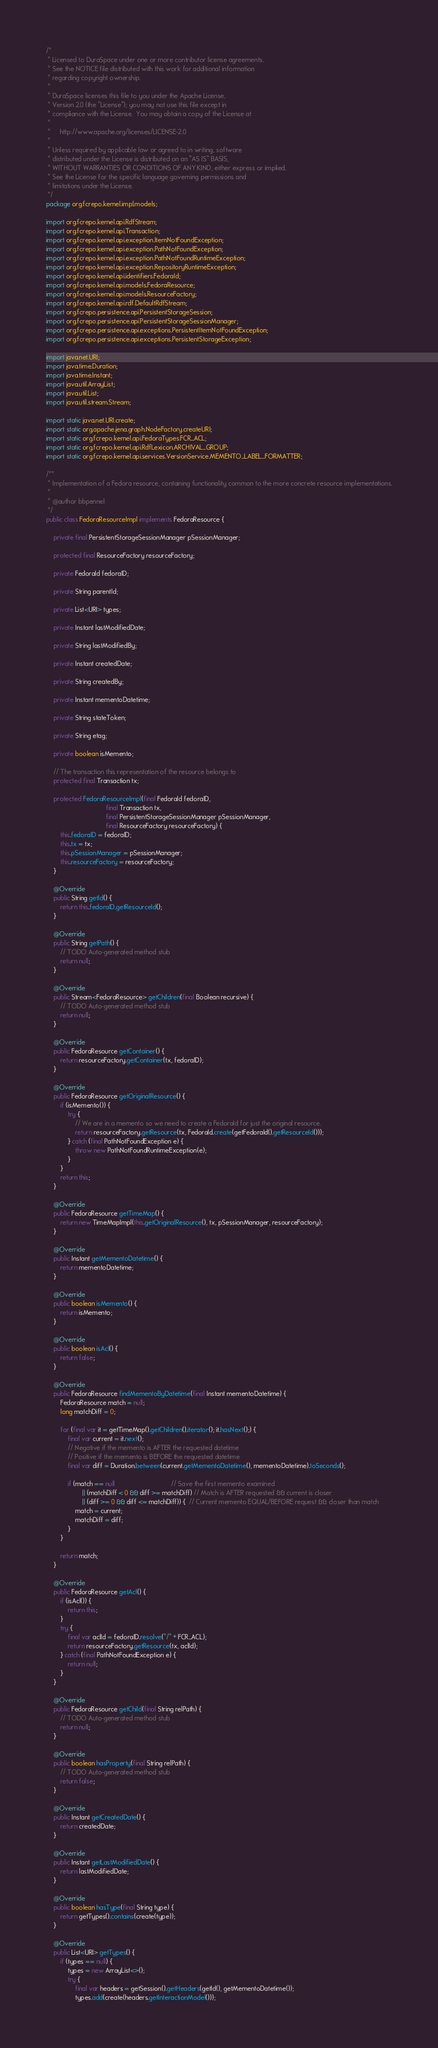<code> <loc_0><loc_0><loc_500><loc_500><_Java_>/*
 * Licensed to DuraSpace under one or more contributor license agreements.
 * See the NOTICE file distributed with this work for additional information
 * regarding copyright ownership.
 *
 * DuraSpace licenses this file to you under the Apache License,
 * Version 2.0 (the "License"); you may not use this file except in
 * compliance with the License.  You may obtain a copy of the License at
 *
 *     http://www.apache.org/licenses/LICENSE-2.0
 *
 * Unless required by applicable law or agreed to in writing, software
 * distributed under the License is distributed on an "AS IS" BASIS,
 * WITHOUT WARRANTIES OR CONDITIONS OF ANY KIND, either express or implied.
 * See the License for the specific language governing permissions and
 * limitations under the License.
 */
package org.fcrepo.kernel.impl.models;

import org.fcrepo.kernel.api.RdfStream;
import org.fcrepo.kernel.api.Transaction;
import org.fcrepo.kernel.api.exception.ItemNotFoundException;
import org.fcrepo.kernel.api.exception.PathNotFoundException;
import org.fcrepo.kernel.api.exception.PathNotFoundRuntimeException;
import org.fcrepo.kernel.api.exception.RepositoryRuntimeException;
import org.fcrepo.kernel.api.identifiers.FedoraId;
import org.fcrepo.kernel.api.models.FedoraResource;
import org.fcrepo.kernel.api.models.ResourceFactory;
import org.fcrepo.kernel.api.rdf.DefaultRdfStream;
import org.fcrepo.persistence.api.PersistentStorageSession;
import org.fcrepo.persistence.api.PersistentStorageSessionManager;
import org.fcrepo.persistence.api.exceptions.PersistentItemNotFoundException;
import org.fcrepo.persistence.api.exceptions.PersistentStorageException;

import java.net.URI;
import java.time.Duration;
import java.time.Instant;
import java.util.ArrayList;
import java.util.List;
import java.util.stream.Stream;

import static java.net.URI.create;
import static org.apache.jena.graph.NodeFactory.createURI;
import static org.fcrepo.kernel.api.FedoraTypes.FCR_ACL;
import static org.fcrepo.kernel.api.RdfLexicon.ARCHIVAL_GROUP;
import static org.fcrepo.kernel.api.services.VersionService.MEMENTO_LABEL_FORMATTER;

/**
 * Implementation of a Fedora resource, containing functionality common to the more concrete resource implementations.
 *
 * @author bbpennel
 */
public class FedoraResourceImpl implements FedoraResource {

    private final PersistentStorageSessionManager pSessionManager;

    protected final ResourceFactory resourceFactory;

    private FedoraId fedoraID;

    private String parentId;

    private List<URI> types;

    private Instant lastModifiedDate;

    private String lastModifiedBy;

    private Instant createdDate;

    private String createdBy;

    private Instant mementoDatetime;

    private String stateToken;

    private String etag;

    private boolean isMemento;

    // The transaction this representation of the resource belongs to
    protected final Transaction tx;

    protected FedoraResourceImpl(final FedoraId fedoraID,
                                 final Transaction tx,
                                 final PersistentStorageSessionManager pSessionManager,
                                 final ResourceFactory resourceFactory) {
        this.fedoraID = fedoraID;
        this.tx = tx;
        this.pSessionManager = pSessionManager;
        this.resourceFactory = resourceFactory;
    }

    @Override
    public String getId() {
        return this.fedoraID.getResourceId();
    }

    @Override
    public String getPath() {
        // TODO Auto-generated method stub
        return null;
    }

    @Override
    public Stream<FedoraResource> getChildren(final Boolean recursive) {
        // TODO Auto-generated method stub
        return null;
    }

    @Override
    public FedoraResource getContainer() {
        return resourceFactory.getContainer(tx, fedoraID);
    }

    @Override
    public FedoraResource getOriginalResource() {
        if (isMemento()) {
            try {
                // We are in a memento so we need to create a FedoraId for just the original resource.
                return resourceFactory.getResource(tx, FedoraId.create(getFedoraId().getResourceId()));
            } catch (final PathNotFoundException e) {
                throw new PathNotFoundRuntimeException(e);
            }
        }
        return this;
    }

    @Override
    public FedoraResource getTimeMap() {
        return new TimeMapImpl(this.getOriginalResource(), tx, pSessionManager, resourceFactory);
    }

    @Override
    public Instant getMementoDatetime() {
        return mementoDatetime;
    }

    @Override
    public boolean isMemento() {
        return isMemento;
    }

    @Override
    public boolean isAcl() {
        return false;
    }

    @Override
    public FedoraResource findMementoByDatetime(final Instant mementoDatetime) {
        FedoraResource match = null;
        long matchDiff = 0;

        for (final var it = getTimeMap().getChildren().iterator(); it.hasNext();) {
            final var current = it.next();
            // Negative if the memento is AFTER the requested datetime
            // Positive if the memento is BEFORE the requested datetime
            final var diff = Duration.between(current.getMementoDatetime(), mementoDatetime).toSeconds();

            if (match == null                               // Save the first memento examined
                    || (matchDiff < 0 && diff >= matchDiff) // Match is AFTER requested && current is closer
                    || (diff >= 0 && diff <= matchDiff)) {  // Current memento EQUAL/BEFORE request && closer than match
                match = current;
                matchDiff = diff;
            }
        }

        return match;
    }

    @Override
    public FedoraResource getAcl() {
        if (isAcl()) {
            return this;
        }
        try {
            final var aclId = fedoraID.resolve("/" + FCR_ACL);
            return resourceFactory.getResource(tx, aclId);
        } catch (final PathNotFoundException e) {
            return null;
        }
    }

    @Override
    public FedoraResource getChild(final String relPath) {
        // TODO Auto-generated method stub
        return null;
    }

    @Override
    public boolean hasProperty(final String relPath) {
        // TODO Auto-generated method stub
        return false;
    }

    @Override
    public Instant getCreatedDate() {
        return createdDate;
    }

    @Override
    public Instant getLastModifiedDate() {
        return lastModifiedDate;
    }

    @Override
    public boolean hasType(final String type) {
        return getTypes().contains(create(type));
    }

    @Override
    public List<URI> getTypes() {
        if (types == null) {
            types = new ArrayList<>();
            try {
                final var headers = getSession().getHeaders(getId(), getMementoDatetime());
                types.add(create(headers.getInteractionModel()));</code> 